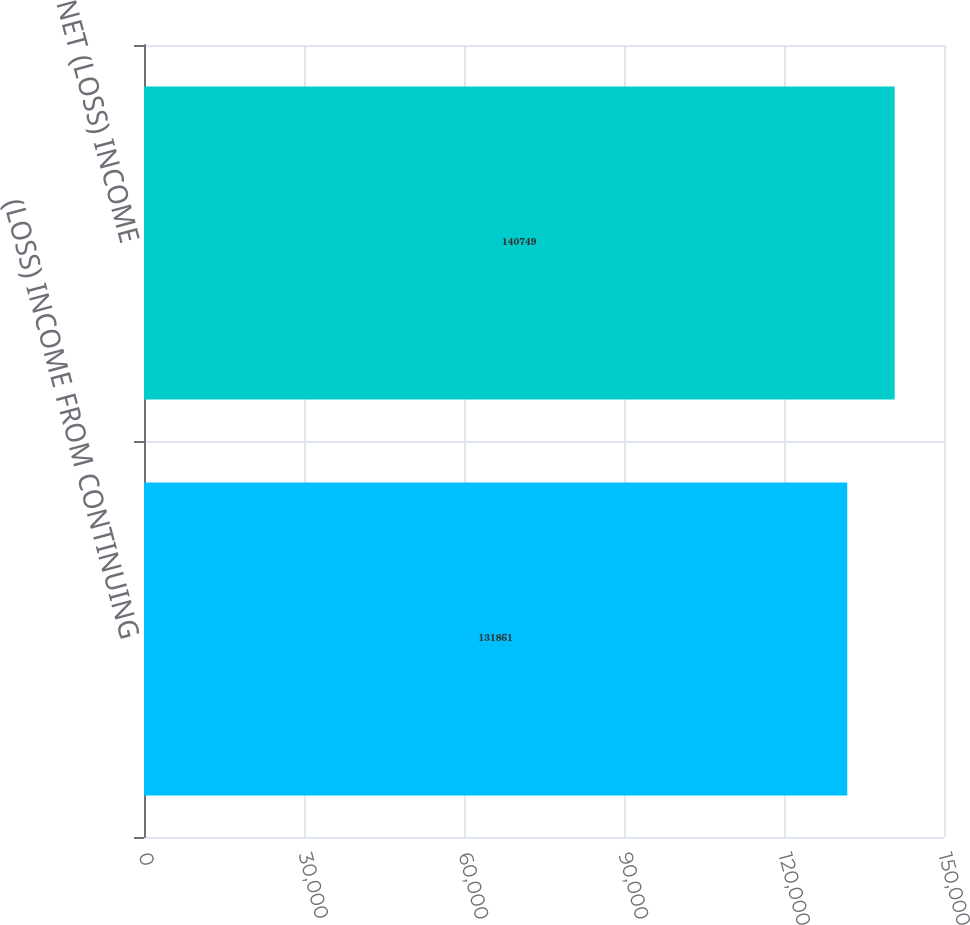Convert chart. <chart><loc_0><loc_0><loc_500><loc_500><bar_chart><fcel>(LOSS) INCOME FROM CONTINUING<fcel>NET (LOSS) INCOME<nl><fcel>131861<fcel>140749<nl></chart> 